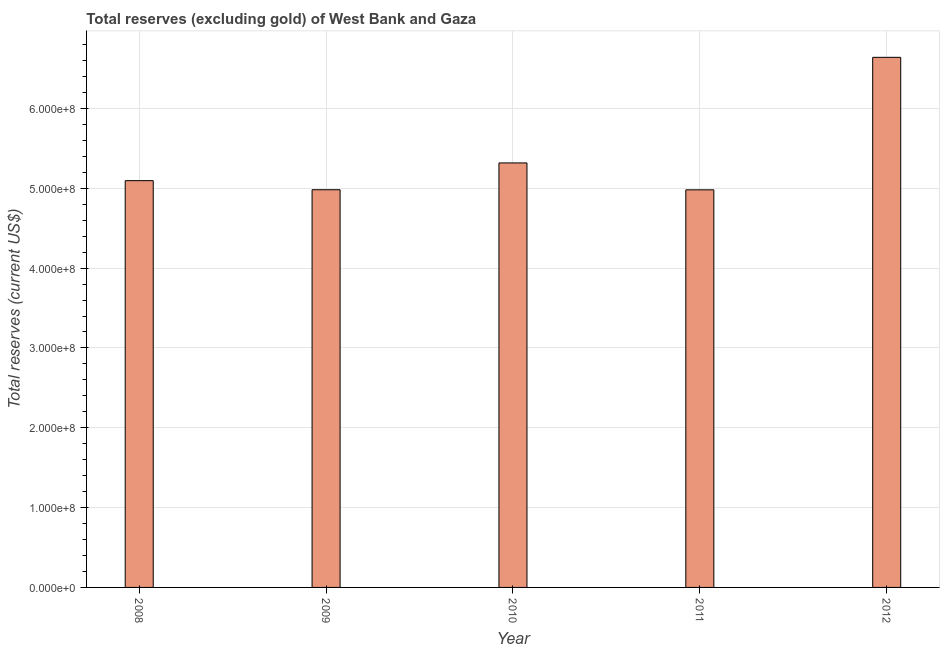Does the graph contain any zero values?
Your answer should be compact. No. Does the graph contain grids?
Offer a terse response. Yes. What is the title of the graph?
Offer a terse response. Total reserves (excluding gold) of West Bank and Gaza. What is the label or title of the X-axis?
Provide a succinct answer. Year. What is the label or title of the Y-axis?
Provide a succinct answer. Total reserves (current US$). What is the total reserves (excluding gold) in 2011?
Give a very brief answer. 4.98e+08. Across all years, what is the maximum total reserves (excluding gold)?
Provide a succinct answer. 6.64e+08. Across all years, what is the minimum total reserves (excluding gold)?
Your answer should be compact. 4.98e+08. What is the sum of the total reserves (excluding gold)?
Make the answer very short. 2.70e+09. What is the difference between the total reserves (excluding gold) in 2008 and 2011?
Provide a short and direct response. 1.15e+07. What is the average total reserves (excluding gold) per year?
Give a very brief answer. 5.40e+08. What is the median total reserves (excluding gold)?
Your answer should be very brief. 5.10e+08. What is the ratio of the total reserves (excluding gold) in 2011 to that in 2012?
Your answer should be very brief. 0.75. Is the total reserves (excluding gold) in 2008 less than that in 2010?
Your response must be concise. Yes. Is the difference between the total reserves (excluding gold) in 2008 and 2010 greater than the difference between any two years?
Give a very brief answer. No. What is the difference between the highest and the second highest total reserves (excluding gold)?
Make the answer very short. 1.32e+08. What is the difference between the highest and the lowest total reserves (excluding gold)?
Make the answer very short. 1.66e+08. How many bars are there?
Offer a very short reply. 5. Are all the bars in the graph horizontal?
Keep it short and to the point. No. How many years are there in the graph?
Your response must be concise. 5. What is the difference between two consecutive major ticks on the Y-axis?
Ensure brevity in your answer.  1.00e+08. Are the values on the major ticks of Y-axis written in scientific E-notation?
Make the answer very short. Yes. What is the Total reserves (current US$) in 2008?
Your response must be concise. 5.10e+08. What is the Total reserves (current US$) of 2009?
Keep it short and to the point. 4.98e+08. What is the Total reserves (current US$) in 2010?
Keep it short and to the point. 5.32e+08. What is the Total reserves (current US$) of 2011?
Provide a succinct answer. 4.98e+08. What is the Total reserves (current US$) of 2012?
Offer a very short reply. 6.64e+08. What is the difference between the Total reserves (current US$) in 2008 and 2009?
Provide a succinct answer. 1.14e+07. What is the difference between the Total reserves (current US$) in 2008 and 2010?
Give a very brief answer. -2.22e+07. What is the difference between the Total reserves (current US$) in 2008 and 2011?
Your answer should be compact. 1.15e+07. What is the difference between the Total reserves (current US$) in 2008 and 2012?
Your answer should be very brief. -1.55e+08. What is the difference between the Total reserves (current US$) in 2009 and 2010?
Give a very brief answer. -3.36e+07. What is the difference between the Total reserves (current US$) in 2009 and 2011?
Your answer should be compact. 1.26e+05. What is the difference between the Total reserves (current US$) in 2009 and 2012?
Give a very brief answer. -1.66e+08. What is the difference between the Total reserves (current US$) in 2010 and 2011?
Provide a succinct answer. 3.37e+07. What is the difference between the Total reserves (current US$) in 2010 and 2012?
Make the answer very short. -1.32e+08. What is the difference between the Total reserves (current US$) in 2011 and 2012?
Your answer should be compact. -1.66e+08. What is the ratio of the Total reserves (current US$) in 2008 to that in 2009?
Make the answer very short. 1.02. What is the ratio of the Total reserves (current US$) in 2008 to that in 2010?
Your answer should be compact. 0.96. What is the ratio of the Total reserves (current US$) in 2008 to that in 2011?
Provide a short and direct response. 1.02. What is the ratio of the Total reserves (current US$) in 2008 to that in 2012?
Make the answer very short. 0.77. What is the ratio of the Total reserves (current US$) in 2009 to that in 2010?
Your response must be concise. 0.94. What is the ratio of the Total reserves (current US$) in 2009 to that in 2011?
Your answer should be very brief. 1. What is the ratio of the Total reserves (current US$) in 2010 to that in 2011?
Make the answer very short. 1.07. What is the ratio of the Total reserves (current US$) in 2010 to that in 2012?
Offer a very short reply. 0.8. 